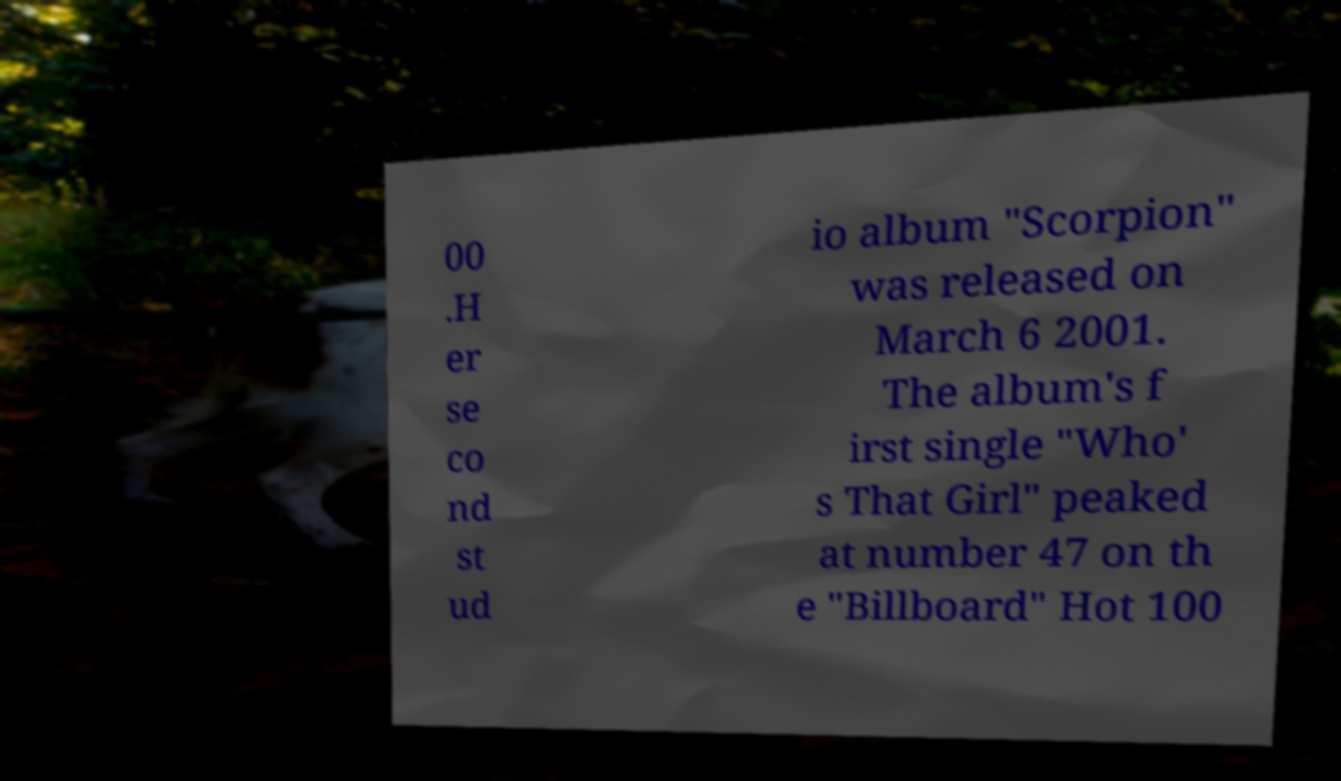Can you read and provide the text displayed in the image?This photo seems to have some interesting text. Can you extract and type it out for me? 00 .H er se co nd st ud io album "Scorpion" was released on March 6 2001. The album's f irst single "Who' s That Girl" peaked at number 47 on th e "Billboard" Hot 100 